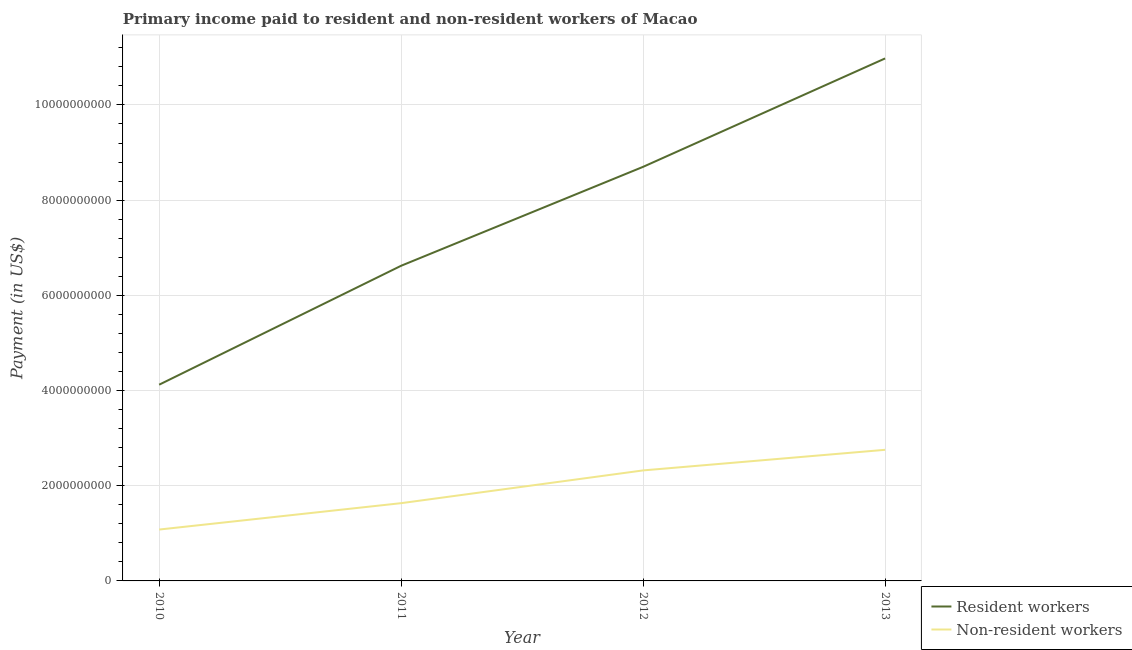How many different coloured lines are there?
Keep it short and to the point. 2. Does the line corresponding to payment made to resident workers intersect with the line corresponding to payment made to non-resident workers?
Provide a short and direct response. No. Is the number of lines equal to the number of legend labels?
Your answer should be compact. Yes. What is the payment made to non-resident workers in 2010?
Give a very brief answer. 1.08e+09. Across all years, what is the maximum payment made to resident workers?
Offer a very short reply. 1.10e+1. Across all years, what is the minimum payment made to non-resident workers?
Provide a succinct answer. 1.08e+09. In which year was the payment made to resident workers maximum?
Your answer should be very brief. 2013. What is the total payment made to non-resident workers in the graph?
Provide a succinct answer. 7.79e+09. What is the difference between the payment made to resident workers in 2010 and that in 2011?
Provide a succinct answer. -2.50e+09. What is the difference between the payment made to resident workers in 2012 and the payment made to non-resident workers in 2010?
Your answer should be compact. 7.62e+09. What is the average payment made to resident workers per year?
Provide a succinct answer. 7.61e+09. In the year 2013, what is the difference between the payment made to resident workers and payment made to non-resident workers?
Offer a very short reply. 8.22e+09. In how many years, is the payment made to non-resident workers greater than 7200000000 US$?
Your answer should be compact. 0. What is the ratio of the payment made to non-resident workers in 2010 to that in 2011?
Ensure brevity in your answer.  0.66. What is the difference between the highest and the second highest payment made to non-resident workers?
Offer a terse response. 4.33e+08. What is the difference between the highest and the lowest payment made to resident workers?
Ensure brevity in your answer.  6.85e+09. In how many years, is the payment made to resident workers greater than the average payment made to resident workers taken over all years?
Offer a very short reply. 2. Does the payment made to non-resident workers monotonically increase over the years?
Provide a succinct answer. Yes. Is the payment made to non-resident workers strictly greater than the payment made to resident workers over the years?
Your answer should be compact. No. Is the payment made to resident workers strictly less than the payment made to non-resident workers over the years?
Your answer should be compact. No. What is the difference between two consecutive major ticks on the Y-axis?
Your answer should be compact. 2.00e+09. Are the values on the major ticks of Y-axis written in scientific E-notation?
Offer a very short reply. No. Does the graph contain any zero values?
Make the answer very short. No. Where does the legend appear in the graph?
Your answer should be very brief. Bottom right. How are the legend labels stacked?
Your answer should be compact. Vertical. What is the title of the graph?
Keep it short and to the point. Primary income paid to resident and non-resident workers of Macao. Does "Unregistered firms" appear as one of the legend labels in the graph?
Your answer should be compact. No. What is the label or title of the Y-axis?
Provide a succinct answer. Payment (in US$). What is the Payment (in US$) in Resident workers in 2010?
Your answer should be very brief. 4.12e+09. What is the Payment (in US$) of Non-resident workers in 2010?
Offer a very short reply. 1.08e+09. What is the Payment (in US$) in Resident workers in 2011?
Make the answer very short. 6.62e+09. What is the Payment (in US$) in Non-resident workers in 2011?
Give a very brief answer. 1.63e+09. What is the Payment (in US$) of Resident workers in 2012?
Make the answer very short. 8.70e+09. What is the Payment (in US$) in Non-resident workers in 2012?
Your response must be concise. 2.32e+09. What is the Payment (in US$) of Resident workers in 2013?
Offer a very short reply. 1.10e+1. What is the Payment (in US$) in Non-resident workers in 2013?
Provide a succinct answer. 2.75e+09. Across all years, what is the maximum Payment (in US$) in Resident workers?
Your response must be concise. 1.10e+1. Across all years, what is the maximum Payment (in US$) of Non-resident workers?
Keep it short and to the point. 2.75e+09. Across all years, what is the minimum Payment (in US$) in Resident workers?
Give a very brief answer. 4.12e+09. Across all years, what is the minimum Payment (in US$) of Non-resident workers?
Keep it short and to the point. 1.08e+09. What is the total Payment (in US$) of Resident workers in the graph?
Give a very brief answer. 3.04e+1. What is the total Payment (in US$) in Non-resident workers in the graph?
Ensure brevity in your answer.  7.79e+09. What is the difference between the Payment (in US$) of Resident workers in 2010 and that in 2011?
Provide a succinct answer. -2.50e+09. What is the difference between the Payment (in US$) in Non-resident workers in 2010 and that in 2011?
Provide a short and direct response. -5.54e+08. What is the difference between the Payment (in US$) of Resident workers in 2010 and that in 2012?
Offer a very short reply. -4.58e+09. What is the difference between the Payment (in US$) of Non-resident workers in 2010 and that in 2012?
Ensure brevity in your answer.  -1.24e+09. What is the difference between the Payment (in US$) of Resident workers in 2010 and that in 2013?
Provide a short and direct response. -6.85e+09. What is the difference between the Payment (in US$) in Non-resident workers in 2010 and that in 2013?
Offer a very short reply. -1.68e+09. What is the difference between the Payment (in US$) in Resident workers in 2011 and that in 2012?
Offer a very short reply. -2.08e+09. What is the difference between the Payment (in US$) of Non-resident workers in 2011 and that in 2012?
Keep it short and to the point. -6.88e+08. What is the difference between the Payment (in US$) in Resident workers in 2011 and that in 2013?
Ensure brevity in your answer.  -4.36e+09. What is the difference between the Payment (in US$) of Non-resident workers in 2011 and that in 2013?
Make the answer very short. -1.12e+09. What is the difference between the Payment (in US$) in Resident workers in 2012 and that in 2013?
Your response must be concise. -2.28e+09. What is the difference between the Payment (in US$) of Non-resident workers in 2012 and that in 2013?
Give a very brief answer. -4.33e+08. What is the difference between the Payment (in US$) of Resident workers in 2010 and the Payment (in US$) of Non-resident workers in 2011?
Your answer should be very brief. 2.49e+09. What is the difference between the Payment (in US$) of Resident workers in 2010 and the Payment (in US$) of Non-resident workers in 2012?
Offer a terse response. 1.80e+09. What is the difference between the Payment (in US$) in Resident workers in 2010 and the Payment (in US$) in Non-resident workers in 2013?
Provide a short and direct response. 1.37e+09. What is the difference between the Payment (in US$) in Resident workers in 2011 and the Payment (in US$) in Non-resident workers in 2012?
Ensure brevity in your answer.  4.30e+09. What is the difference between the Payment (in US$) in Resident workers in 2011 and the Payment (in US$) in Non-resident workers in 2013?
Your response must be concise. 3.87e+09. What is the difference between the Payment (in US$) of Resident workers in 2012 and the Payment (in US$) of Non-resident workers in 2013?
Provide a short and direct response. 5.95e+09. What is the average Payment (in US$) of Resident workers per year?
Offer a very short reply. 7.61e+09. What is the average Payment (in US$) in Non-resident workers per year?
Your answer should be compact. 1.95e+09. In the year 2010, what is the difference between the Payment (in US$) in Resident workers and Payment (in US$) in Non-resident workers?
Offer a very short reply. 3.04e+09. In the year 2011, what is the difference between the Payment (in US$) in Resident workers and Payment (in US$) in Non-resident workers?
Provide a short and direct response. 4.99e+09. In the year 2012, what is the difference between the Payment (in US$) of Resident workers and Payment (in US$) of Non-resident workers?
Your answer should be very brief. 6.38e+09. In the year 2013, what is the difference between the Payment (in US$) of Resident workers and Payment (in US$) of Non-resident workers?
Keep it short and to the point. 8.22e+09. What is the ratio of the Payment (in US$) of Resident workers in 2010 to that in 2011?
Your answer should be very brief. 0.62. What is the ratio of the Payment (in US$) of Non-resident workers in 2010 to that in 2011?
Keep it short and to the point. 0.66. What is the ratio of the Payment (in US$) in Resident workers in 2010 to that in 2012?
Your answer should be very brief. 0.47. What is the ratio of the Payment (in US$) of Non-resident workers in 2010 to that in 2012?
Give a very brief answer. 0.46. What is the ratio of the Payment (in US$) of Resident workers in 2010 to that in 2013?
Ensure brevity in your answer.  0.38. What is the ratio of the Payment (in US$) of Non-resident workers in 2010 to that in 2013?
Your response must be concise. 0.39. What is the ratio of the Payment (in US$) in Resident workers in 2011 to that in 2012?
Provide a short and direct response. 0.76. What is the ratio of the Payment (in US$) of Non-resident workers in 2011 to that in 2012?
Keep it short and to the point. 0.7. What is the ratio of the Payment (in US$) in Resident workers in 2011 to that in 2013?
Your answer should be compact. 0.6. What is the ratio of the Payment (in US$) in Non-resident workers in 2011 to that in 2013?
Make the answer very short. 0.59. What is the ratio of the Payment (in US$) in Resident workers in 2012 to that in 2013?
Offer a very short reply. 0.79. What is the ratio of the Payment (in US$) of Non-resident workers in 2012 to that in 2013?
Provide a short and direct response. 0.84. What is the difference between the highest and the second highest Payment (in US$) in Resident workers?
Provide a succinct answer. 2.28e+09. What is the difference between the highest and the second highest Payment (in US$) in Non-resident workers?
Ensure brevity in your answer.  4.33e+08. What is the difference between the highest and the lowest Payment (in US$) in Resident workers?
Provide a succinct answer. 6.85e+09. What is the difference between the highest and the lowest Payment (in US$) in Non-resident workers?
Your answer should be very brief. 1.68e+09. 